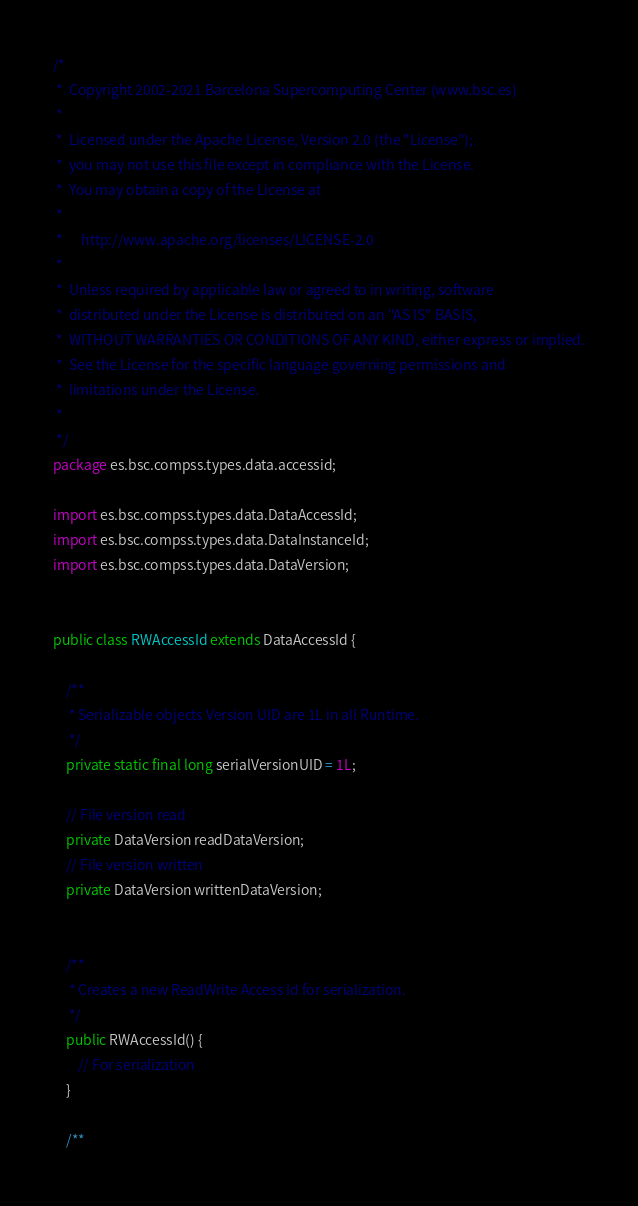Convert code to text. <code><loc_0><loc_0><loc_500><loc_500><_Java_>/*
 *  Copyright 2002-2021 Barcelona Supercomputing Center (www.bsc.es)
 *
 *  Licensed under the Apache License, Version 2.0 (the "License");
 *  you may not use this file except in compliance with the License.
 *  You may obtain a copy of the License at
 *
 *      http://www.apache.org/licenses/LICENSE-2.0
 *
 *  Unless required by applicable law or agreed to in writing, software
 *  distributed under the License is distributed on an "AS IS" BASIS,
 *  WITHOUT WARRANTIES OR CONDITIONS OF ANY KIND, either express or implied.
 *  See the License for the specific language governing permissions and
 *  limitations under the License.
 *
 */
package es.bsc.compss.types.data.accessid;

import es.bsc.compss.types.data.DataAccessId;
import es.bsc.compss.types.data.DataInstanceId;
import es.bsc.compss.types.data.DataVersion;


public class RWAccessId extends DataAccessId {

    /**
     * Serializable objects Version UID are 1L in all Runtime.
     */
    private static final long serialVersionUID = 1L;

    // File version read
    private DataVersion readDataVersion;
    // File version written
    private DataVersion writtenDataVersion;


    /**
     * Creates a new ReadWrite Access Id for serialization.
     */
    public RWAccessId() {
        // For serialization
    }

    /**</code> 